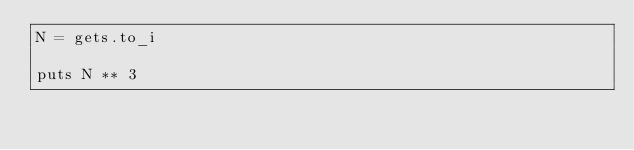<code> <loc_0><loc_0><loc_500><loc_500><_Ruby_>N = gets.to_i

puts N ** 3
</code> 